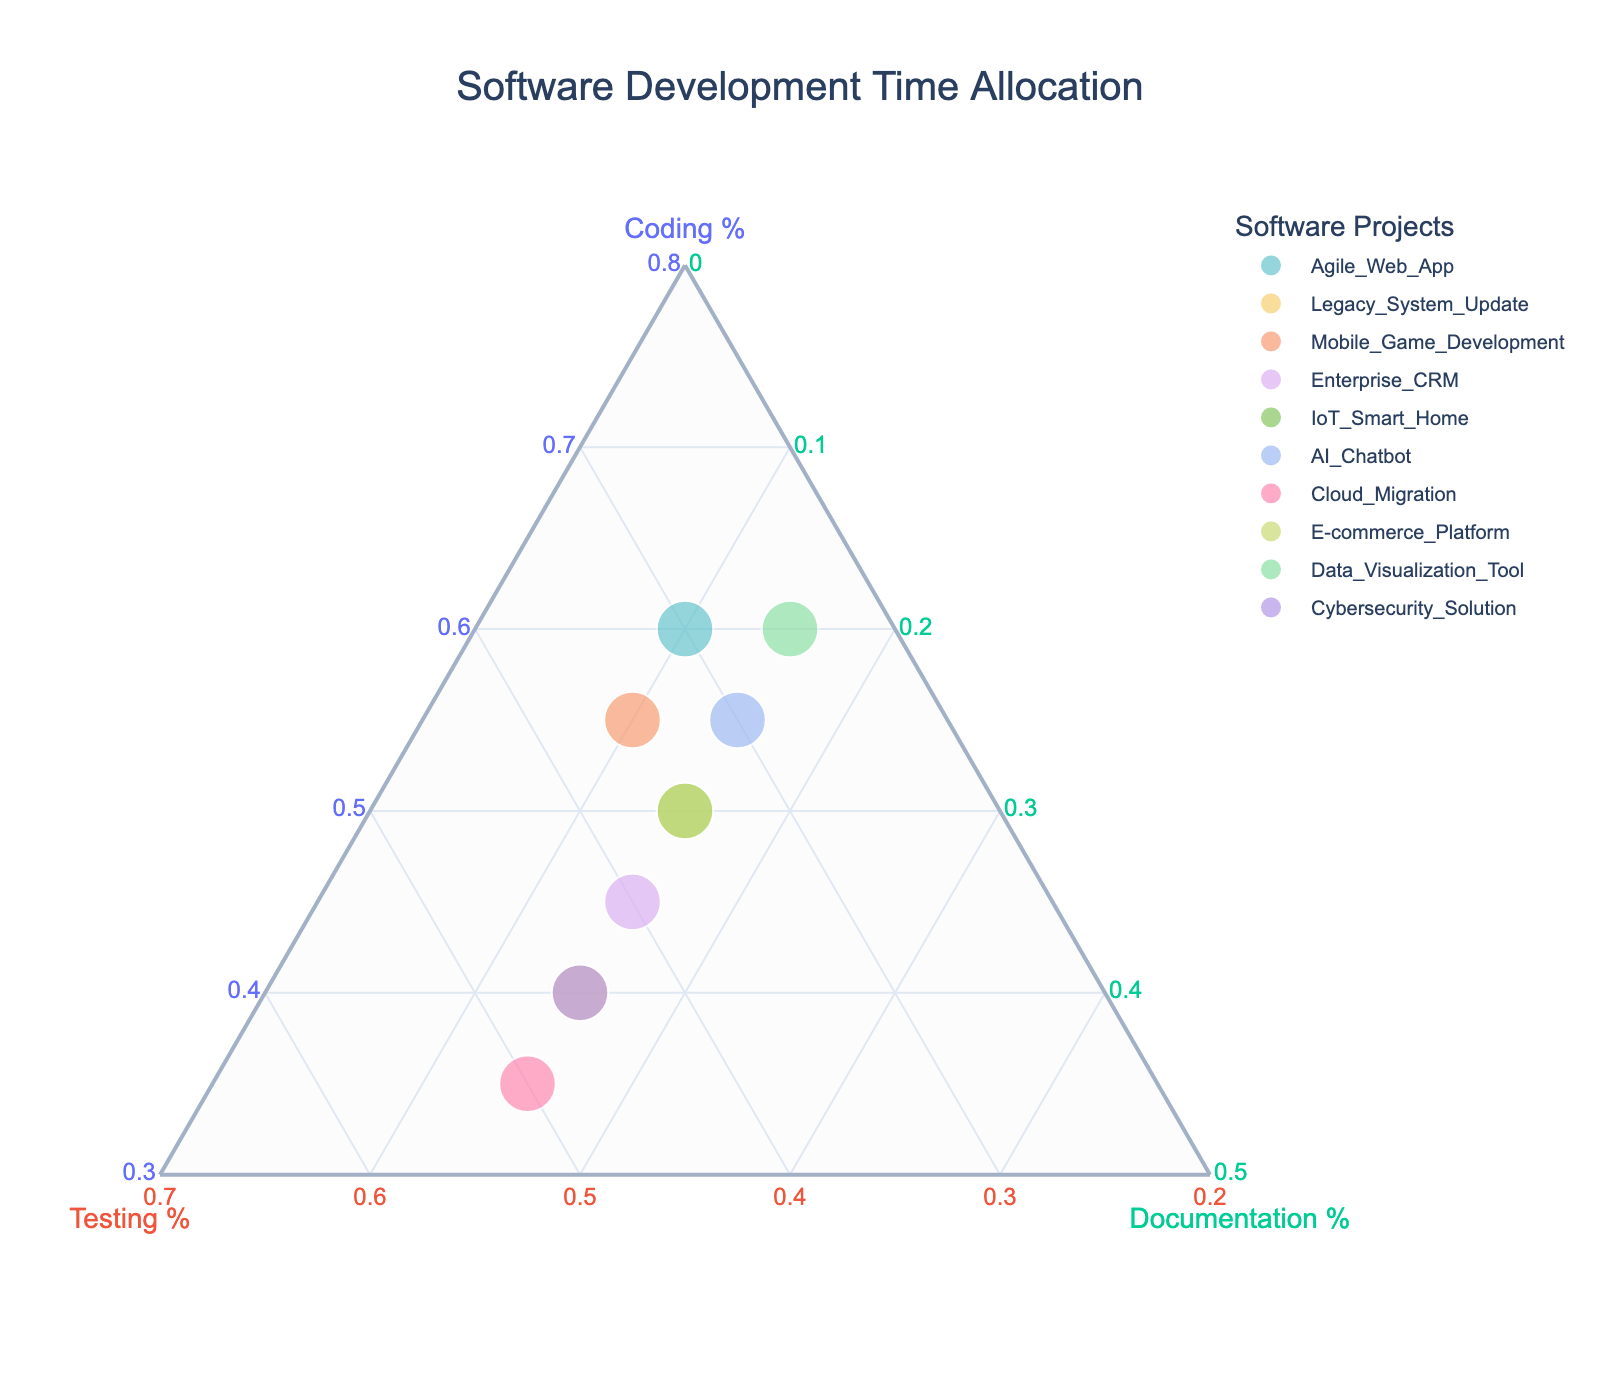What is the title of the ternary plot? The title of the ternary plot is typically located at the top of the plot. In this case, it is "Software Development Time Allocation."
Answer: Software Development Time Allocation Which software project allocates the most time to Testing? By looking at the Testing axis, we see the project with the highest value along this axis. From the figure, "Cloud_Migration" allocates the most time to Testing with 50%.
Answer: Cloud_Migration What's the minimum percentage allocated to Documentation among the projects? The Documentation axis indicates the percentage allocated to documentation. From the plot, the minimum percentage allocated to Documentation happens to be 10%.
Answer: 10% How many projects allocate exactly 15% to Documentation? By observing the Documentation axis, we identify the number of points positioned at the 15% mark. There are 6 projects that allocate exactly 15% to Documentation.
Answer: 6 Which project spends equal time on Coding and Testing? Check the points along the diagonal where the Coding and Testing percentages are equal. From the plot, "Cybersecurity_Solution" is one such project, with 40% on both.
Answer: Cybersecurity_Solution What is the average percentage allocation to Coding across all projects? Add the percentages allocated to Coding for each project and divide by the number of projects. (60 + 40 + 55 + 45 + 50 + 55 + 35 + 50 + 60 + 40) / 10 = 49%.
Answer: 49% How does the time allocation of Agile_Web_App compare to AI_Chatbot in terms of Testing? Compare the percentages dedicated to Testing for both projects by looking at their positions along the Testing axis. Agile_Web_App allocates 30%, while AI_Chatbot allocates the same amount at 30%. They are equal in terms of Testing allocation.
Answer: Equal Which project(s) allocate more than 50% to Coding? Look for points where the Coding axis value is greater than 50%. The projects that allocate more than 50% to Coding are "Agile_Web_App", "Mobile_Game_Development", "AI_Chatbot", and "Data_Visualization_Tool."
Answer: Agile_Web_App, Mobile_Game_Development, AI_Chatbot, Data_Visualization_Tool Which project allocates the least time to Coding? Find the project with the lowest percentage along the Coding axis. "Cloud_Migration" allocates the least time to Coding at 35%.
Answer: Cloud_Migration Among all projects, what is the most common percentage allocation for Documentation? Check the Documentation axis for the value that appears most frequently. 15% is the most common percentage allocation for Documentation, appearing in six projects.
Answer: 15% 